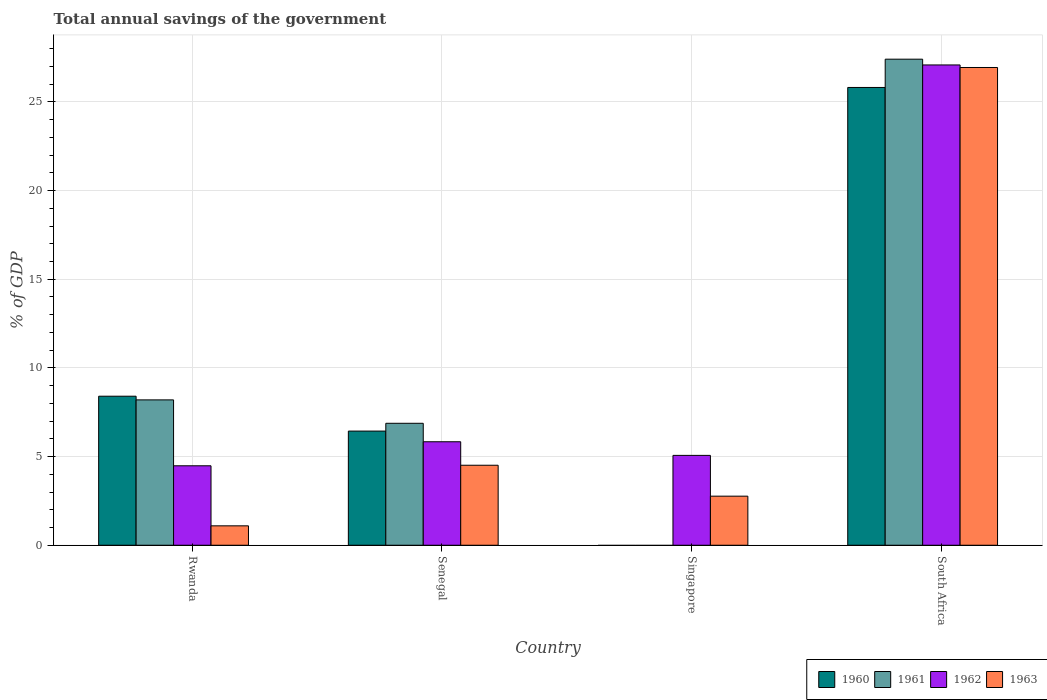How many different coloured bars are there?
Provide a succinct answer. 4. Are the number of bars per tick equal to the number of legend labels?
Your answer should be very brief. No. What is the label of the 3rd group of bars from the left?
Provide a succinct answer. Singapore. What is the total annual savings of the government in 1961 in Singapore?
Ensure brevity in your answer.  0. Across all countries, what is the maximum total annual savings of the government in 1962?
Provide a short and direct response. 27.08. Across all countries, what is the minimum total annual savings of the government in 1961?
Provide a short and direct response. 0. In which country was the total annual savings of the government in 1960 maximum?
Your answer should be compact. South Africa. What is the total total annual savings of the government in 1962 in the graph?
Your answer should be very brief. 42.47. What is the difference between the total annual savings of the government in 1963 in Rwanda and that in South Africa?
Give a very brief answer. -25.85. What is the difference between the total annual savings of the government in 1960 in Rwanda and the total annual savings of the government in 1962 in Singapore?
Your response must be concise. 3.34. What is the average total annual savings of the government in 1962 per country?
Provide a short and direct response. 10.62. What is the difference between the total annual savings of the government of/in 1962 and total annual savings of the government of/in 1963 in South Africa?
Your answer should be very brief. 0.14. In how many countries, is the total annual savings of the government in 1961 greater than 24 %?
Keep it short and to the point. 1. What is the ratio of the total annual savings of the government in 1963 in Senegal to that in South Africa?
Keep it short and to the point. 0.17. Is the total annual savings of the government in 1962 in Rwanda less than that in South Africa?
Your response must be concise. Yes. Is the difference between the total annual savings of the government in 1962 in Singapore and South Africa greater than the difference between the total annual savings of the government in 1963 in Singapore and South Africa?
Provide a short and direct response. Yes. What is the difference between the highest and the second highest total annual savings of the government in 1963?
Provide a succinct answer. 24.17. What is the difference between the highest and the lowest total annual savings of the government in 1963?
Offer a terse response. 25.85. In how many countries, is the total annual savings of the government in 1963 greater than the average total annual savings of the government in 1963 taken over all countries?
Offer a very short reply. 1. Is the sum of the total annual savings of the government in 1962 in Senegal and Singapore greater than the maximum total annual savings of the government in 1961 across all countries?
Provide a succinct answer. No. Is it the case that in every country, the sum of the total annual savings of the government in 1961 and total annual savings of the government in 1962 is greater than the total annual savings of the government in 1960?
Provide a succinct answer. Yes. Are the values on the major ticks of Y-axis written in scientific E-notation?
Offer a very short reply. No. Does the graph contain any zero values?
Offer a very short reply. Yes. Does the graph contain grids?
Make the answer very short. Yes. What is the title of the graph?
Provide a short and direct response. Total annual savings of the government. What is the label or title of the X-axis?
Give a very brief answer. Country. What is the label or title of the Y-axis?
Offer a terse response. % of GDP. What is the % of GDP of 1960 in Rwanda?
Offer a very short reply. 8.4. What is the % of GDP in 1961 in Rwanda?
Make the answer very short. 8.2. What is the % of GDP in 1962 in Rwanda?
Offer a terse response. 4.48. What is the % of GDP in 1963 in Rwanda?
Your response must be concise. 1.09. What is the % of GDP in 1960 in Senegal?
Offer a terse response. 6.44. What is the % of GDP in 1961 in Senegal?
Keep it short and to the point. 6.88. What is the % of GDP in 1962 in Senegal?
Make the answer very short. 5.83. What is the % of GDP in 1963 in Senegal?
Keep it short and to the point. 4.51. What is the % of GDP of 1960 in Singapore?
Your answer should be compact. 0. What is the % of GDP in 1961 in Singapore?
Your response must be concise. 0. What is the % of GDP in 1962 in Singapore?
Provide a succinct answer. 5.07. What is the % of GDP of 1963 in Singapore?
Your answer should be very brief. 2.77. What is the % of GDP in 1960 in South Africa?
Your answer should be very brief. 25.81. What is the % of GDP in 1961 in South Africa?
Your response must be concise. 27.41. What is the % of GDP in 1962 in South Africa?
Give a very brief answer. 27.08. What is the % of GDP of 1963 in South Africa?
Keep it short and to the point. 26.94. Across all countries, what is the maximum % of GDP of 1960?
Offer a very short reply. 25.81. Across all countries, what is the maximum % of GDP of 1961?
Your answer should be very brief. 27.41. Across all countries, what is the maximum % of GDP in 1962?
Your answer should be compact. 27.08. Across all countries, what is the maximum % of GDP in 1963?
Offer a very short reply. 26.94. Across all countries, what is the minimum % of GDP in 1960?
Ensure brevity in your answer.  0. Across all countries, what is the minimum % of GDP in 1961?
Offer a very short reply. 0. Across all countries, what is the minimum % of GDP in 1962?
Offer a terse response. 4.48. Across all countries, what is the minimum % of GDP in 1963?
Make the answer very short. 1.09. What is the total % of GDP in 1960 in the graph?
Your answer should be very brief. 40.66. What is the total % of GDP of 1961 in the graph?
Ensure brevity in your answer.  42.48. What is the total % of GDP in 1962 in the graph?
Provide a short and direct response. 42.47. What is the total % of GDP of 1963 in the graph?
Your response must be concise. 35.31. What is the difference between the % of GDP in 1960 in Rwanda and that in Senegal?
Give a very brief answer. 1.97. What is the difference between the % of GDP in 1961 in Rwanda and that in Senegal?
Ensure brevity in your answer.  1.32. What is the difference between the % of GDP of 1962 in Rwanda and that in Senegal?
Offer a terse response. -1.35. What is the difference between the % of GDP in 1963 in Rwanda and that in Senegal?
Ensure brevity in your answer.  -3.42. What is the difference between the % of GDP in 1962 in Rwanda and that in Singapore?
Give a very brief answer. -0.59. What is the difference between the % of GDP in 1963 in Rwanda and that in Singapore?
Make the answer very short. -1.67. What is the difference between the % of GDP of 1960 in Rwanda and that in South Africa?
Offer a terse response. -17.41. What is the difference between the % of GDP in 1961 in Rwanda and that in South Africa?
Make the answer very short. -19.21. What is the difference between the % of GDP in 1962 in Rwanda and that in South Africa?
Offer a terse response. -22.6. What is the difference between the % of GDP of 1963 in Rwanda and that in South Africa?
Ensure brevity in your answer.  -25.85. What is the difference between the % of GDP of 1962 in Senegal and that in Singapore?
Your response must be concise. 0.77. What is the difference between the % of GDP of 1963 in Senegal and that in Singapore?
Your answer should be very brief. 1.74. What is the difference between the % of GDP in 1960 in Senegal and that in South Africa?
Ensure brevity in your answer.  -19.38. What is the difference between the % of GDP of 1961 in Senegal and that in South Africa?
Make the answer very short. -20.53. What is the difference between the % of GDP of 1962 in Senegal and that in South Africa?
Provide a succinct answer. -21.25. What is the difference between the % of GDP of 1963 in Senegal and that in South Africa?
Offer a very short reply. -22.43. What is the difference between the % of GDP of 1962 in Singapore and that in South Africa?
Give a very brief answer. -22.02. What is the difference between the % of GDP in 1963 in Singapore and that in South Africa?
Give a very brief answer. -24.17. What is the difference between the % of GDP of 1960 in Rwanda and the % of GDP of 1961 in Senegal?
Your answer should be very brief. 1.53. What is the difference between the % of GDP in 1960 in Rwanda and the % of GDP in 1962 in Senegal?
Offer a terse response. 2.57. What is the difference between the % of GDP of 1960 in Rwanda and the % of GDP of 1963 in Senegal?
Your answer should be compact. 3.89. What is the difference between the % of GDP of 1961 in Rwanda and the % of GDP of 1962 in Senegal?
Make the answer very short. 2.36. What is the difference between the % of GDP in 1961 in Rwanda and the % of GDP in 1963 in Senegal?
Your response must be concise. 3.69. What is the difference between the % of GDP of 1962 in Rwanda and the % of GDP of 1963 in Senegal?
Provide a succinct answer. -0.03. What is the difference between the % of GDP of 1960 in Rwanda and the % of GDP of 1962 in Singapore?
Your answer should be very brief. 3.34. What is the difference between the % of GDP in 1960 in Rwanda and the % of GDP in 1963 in Singapore?
Your response must be concise. 5.64. What is the difference between the % of GDP of 1961 in Rwanda and the % of GDP of 1962 in Singapore?
Your answer should be very brief. 3.13. What is the difference between the % of GDP of 1961 in Rwanda and the % of GDP of 1963 in Singapore?
Make the answer very short. 5.43. What is the difference between the % of GDP of 1962 in Rwanda and the % of GDP of 1963 in Singapore?
Make the answer very short. 1.71. What is the difference between the % of GDP of 1960 in Rwanda and the % of GDP of 1961 in South Africa?
Make the answer very short. -19.01. What is the difference between the % of GDP of 1960 in Rwanda and the % of GDP of 1962 in South Africa?
Make the answer very short. -18.68. What is the difference between the % of GDP of 1960 in Rwanda and the % of GDP of 1963 in South Africa?
Ensure brevity in your answer.  -18.54. What is the difference between the % of GDP in 1961 in Rwanda and the % of GDP in 1962 in South Africa?
Provide a short and direct response. -18.89. What is the difference between the % of GDP of 1961 in Rwanda and the % of GDP of 1963 in South Africa?
Keep it short and to the point. -18.74. What is the difference between the % of GDP in 1962 in Rwanda and the % of GDP in 1963 in South Africa?
Your response must be concise. -22.46. What is the difference between the % of GDP of 1960 in Senegal and the % of GDP of 1962 in Singapore?
Make the answer very short. 1.37. What is the difference between the % of GDP in 1960 in Senegal and the % of GDP in 1963 in Singapore?
Give a very brief answer. 3.67. What is the difference between the % of GDP in 1961 in Senegal and the % of GDP in 1962 in Singapore?
Give a very brief answer. 1.81. What is the difference between the % of GDP of 1961 in Senegal and the % of GDP of 1963 in Singapore?
Provide a succinct answer. 4.11. What is the difference between the % of GDP of 1962 in Senegal and the % of GDP of 1963 in Singapore?
Give a very brief answer. 3.07. What is the difference between the % of GDP of 1960 in Senegal and the % of GDP of 1961 in South Africa?
Provide a short and direct response. -20.97. What is the difference between the % of GDP of 1960 in Senegal and the % of GDP of 1962 in South Africa?
Ensure brevity in your answer.  -20.65. What is the difference between the % of GDP in 1960 in Senegal and the % of GDP in 1963 in South Africa?
Give a very brief answer. -20.5. What is the difference between the % of GDP in 1961 in Senegal and the % of GDP in 1962 in South Africa?
Provide a short and direct response. -20.21. What is the difference between the % of GDP in 1961 in Senegal and the % of GDP in 1963 in South Africa?
Offer a very short reply. -20.06. What is the difference between the % of GDP of 1962 in Senegal and the % of GDP of 1963 in South Africa?
Your response must be concise. -21.11. What is the difference between the % of GDP in 1962 in Singapore and the % of GDP in 1963 in South Africa?
Provide a succinct answer. -21.87. What is the average % of GDP of 1960 per country?
Your answer should be compact. 10.16. What is the average % of GDP of 1961 per country?
Provide a short and direct response. 10.62. What is the average % of GDP in 1962 per country?
Provide a succinct answer. 10.62. What is the average % of GDP of 1963 per country?
Give a very brief answer. 8.83. What is the difference between the % of GDP of 1960 and % of GDP of 1961 in Rwanda?
Provide a short and direct response. 0.21. What is the difference between the % of GDP in 1960 and % of GDP in 1962 in Rwanda?
Ensure brevity in your answer.  3.92. What is the difference between the % of GDP of 1960 and % of GDP of 1963 in Rwanda?
Give a very brief answer. 7.31. What is the difference between the % of GDP of 1961 and % of GDP of 1962 in Rwanda?
Offer a terse response. 3.72. What is the difference between the % of GDP in 1961 and % of GDP in 1963 in Rwanda?
Make the answer very short. 7.1. What is the difference between the % of GDP in 1962 and % of GDP in 1963 in Rwanda?
Keep it short and to the point. 3.39. What is the difference between the % of GDP of 1960 and % of GDP of 1961 in Senegal?
Your response must be concise. -0.44. What is the difference between the % of GDP of 1960 and % of GDP of 1962 in Senegal?
Your answer should be compact. 0.6. What is the difference between the % of GDP in 1960 and % of GDP in 1963 in Senegal?
Keep it short and to the point. 1.93. What is the difference between the % of GDP in 1961 and % of GDP in 1962 in Senegal?
Your answer should be very brief. 1.04. What is the difference between the % of GDP of 1961 and % of GDP of 1963 in Senegal?
Give a very brief answer. 2.37. What is the difference between the % of GDP in 1962 and % of GDP in 1963 in Senegal?
Offer a very short reply. 1.32. What is the difference between the % of GDP of 1962 and % of GDP of 1963 in Singapore?
Make the answer very short. 2.3. What is the difference between the % of GDP in 1960 and % of GDP in 1961 in South Africa?
Offer a very short reply. -1.59. What is the difference between the % of GDP of 1960 and % of GDP of 1962 in South Africa?
Give a very brief answer. -1.27. What is the difference between the % of GDP of 1960 and % of GDP of 1963 in South Africa?
Keep it short and to the point. -1.13. What is the difference between the % of GDP in 1961 and % of GDP in 1962 in South Africa?
Provide a short and direct response. 0.33. What is the difference between the % of GDP of 1961 and % of GDP of 1963 in South Africa?
Your answer should be very brief. 0.47. What is the difference between the % of GDP of 1962 and % of GDP of 1963 in South Africa?
Provide a short and direct response. 0.14. What is the ratio of the % of GDP of 1960 in Rwanda to that in Senegal?
Keep it short and to the point. 1.31. What is the ratio of the % of GDP in 1961 in Rwanda to that in Senegal?
Your answer should be compact. 1.19. What is the ratio of the % of GDP of 1962 in Rwanda to that in Senegal?
Offer a very short reply. 0.77. What is the ratio of the % of GDP of 1963 in Rwanda to that in Senegal?
Give a very brief answer. 0.24. What is the ratio of the % of GDP of 1962 in Rwanda to that in Singapore?
Provide a short and direct response. 0.88. What is the ratio of the % of GDP in 1963 in Rwanda to that in Singapore?
Ensure brevity in your answer.  0.4. What is the ratio of the % of GDP in 1960 in Rwanda to that in South Africa?
Offer a very short reply. 0.33. What is the ratio of the % of GDP in 1961 in Rwanda to that in South Africa?
Offer a very short reply. 0.3. What is the ratio of the % of GDP of 1962 in Rwanda to that in South Africa?
Your answer should be compact. 0.17. What is the ratio of the % of GDP of 1963 in Rwanda to that in South Africa?
Your response must be concise. 0.04. What is the ratio of the % of GDP in 1962 in Senegal to that in Singapore?
Provide a short and direct response. 1.15. What is the ratio of the % of GDP of 1963 in Senegal to that in Singapore?
Your response must be concise. 1.63. What is the ratio of the % of GDP of 1960 in Senegal to that in South Africa?
Make the answer very short. 0.25. What is the ratio of the % of GDP of 1961 in Senegal to that in South Africa?
Make the answer very short. 0.25. What is the ratio of the % of GDP of 1962 in Senegal to that in South Africa?
Your response must be concise. 0.22. What is the ratio of the % of GDP of 1963 in Senegal to that in South Africa?
Provide a succinct answer. 0.17. What is the ratio of the % of GDP of 1962 in Singapore to that in South Africa?
Provide a short and direct response. 0.19. What is the ratio of the % of GDP in 1963 in Singapore to that in South Africa?
Offer a terse response. 0.1. What is the difference between the highest and the second highest % of GDP in 1960?
Your answer should be compact. 17.41. What is the difference between the highest and the second highest % of GDP of 1961?
Make the answer very short. 19.21. What is the difference between the highest and the second highest % of GDP in 1962?
Make the answer very short. 21.25. What is the difference between the highest and the second highest % of GDP in 1963?
Give a very brief answer. 22.43. What is the difference between the highest and the lowest % of GDP of 1960?
Provide a succinct answer. 25.81. What is the difference between the highest and the lowest % of GDP in 1961?
Offer a terse response. 27.41. What is the difference between the highest and the lowest % of GDP in 1962?
Provide a succinct answer. 22.6. What is the difference between the highest and the lowest % of GDP in 1963?
Keep it short and to the point. 25.85. 